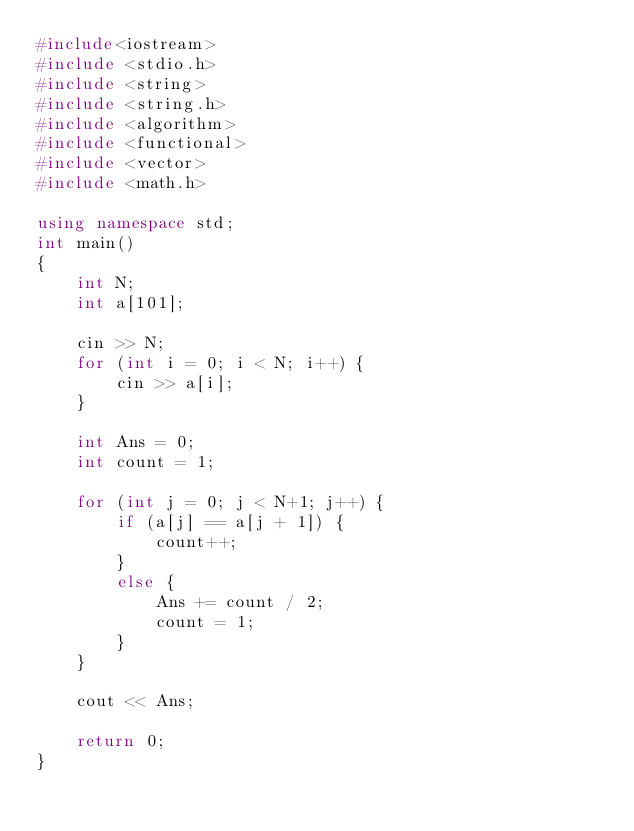Convert code to text. <code><loc_0><loc_0><loc_500><loc_500><_C++_>#include<iostream>
#include <stdio.h>
#include <string>
#include <string.h>
#include <algorithm>
#include <functional>
#include <vector>
#include <math.h>

using namespace std;
int main()
{
	int N;
	int a[101];

	cin >> N;
	for (int i = 0; i < N; i++) {
		cin >> a[i];
	}

	int Ans = 0;
	int count = 1;

	for (int j = 0; j < N+1; j++) {
		if (a[j] == a[j + 1]) {
			count++;
		}
		else { 
			Ans += count / 2;
			count = 1;
		}
	}

	cout << Ans;

	return 0;
}</code> 